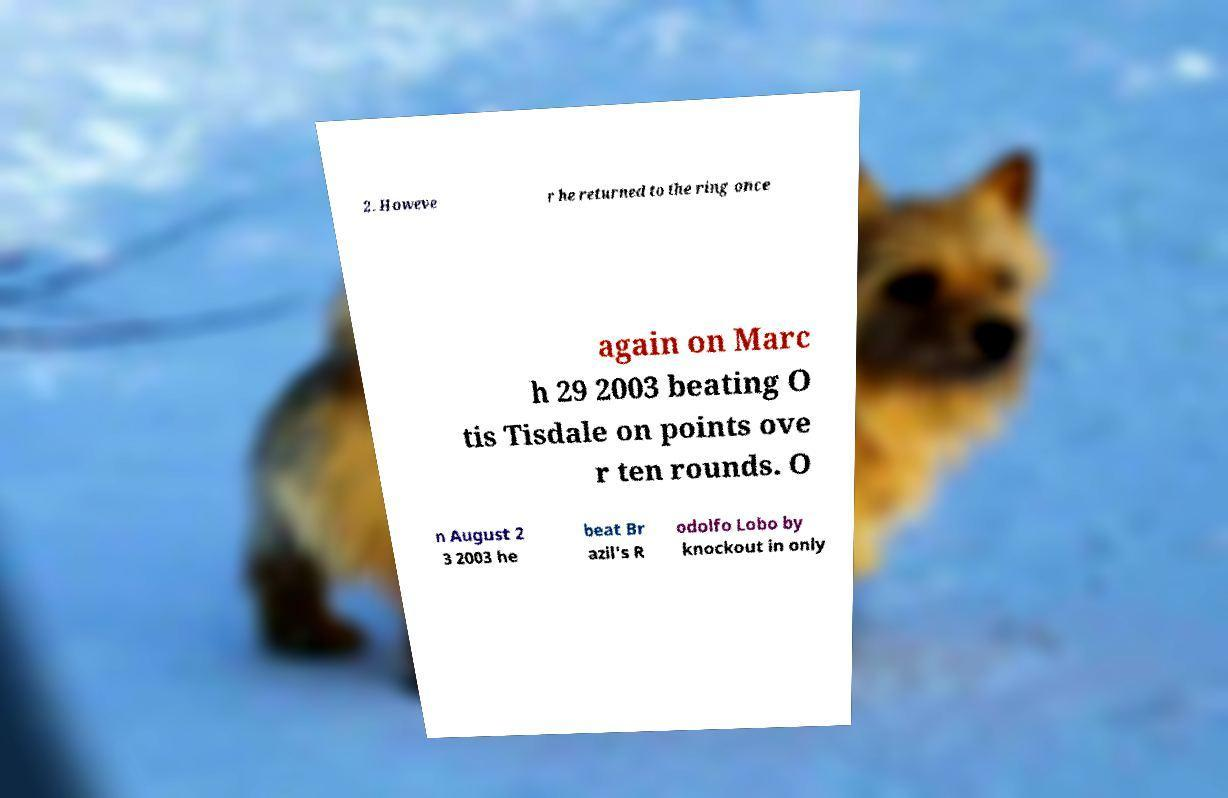Please read and relay the text visible in this image. What does it say? 2. Howeve r he returned to the ring once again on Marc h 29 2003 beating O tis Tisdale on points ove r ten rounds. O n August 2 3 2003 he beat Br azil's R odolfo Lobo by knockout in only 